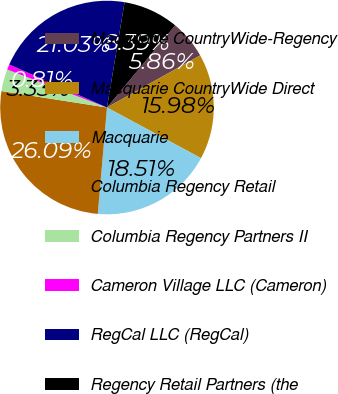Convert chart to OTSL. <chart><loc_0><loc_0><loc_500><loc_500><pie_chart><fcel>Macquarie CountryWide-Regency<fcel>Macquarie CountryWide Direct<fcel>Macquarie<fcel>Columbia Regency Retail<fcel>Columbia Regency Partners II<fcel>Cameron Village LLC (Cameron)<fcel>RegCal LLC (RegCal)<fcel>Regency Retail Partners (the<nl><fcel>5.86%<fcel>15.98%<fcel>18.51%<fcel>26.09%<fcel>3.33%<fcel>0.81%<fcel>21.03%<fcel>8.39%<nl></chart> 